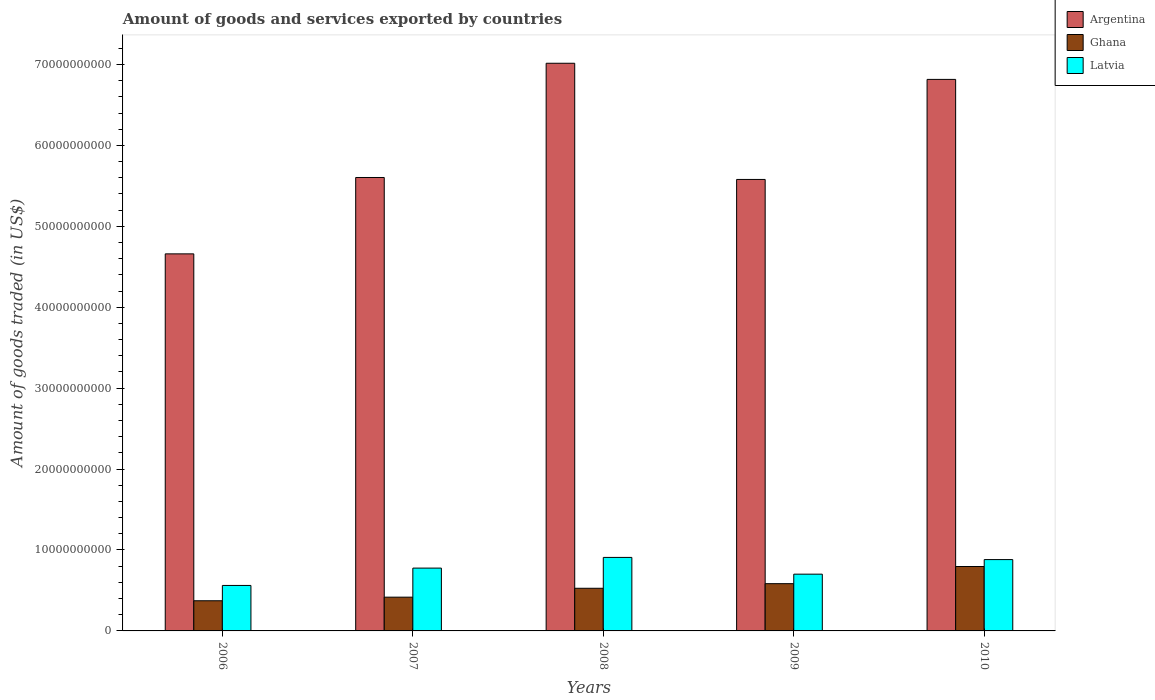How many groups of bars are there?
Provide a short and direct response. 5. What is the label of the 1st group of bars from the left?
Your answer should be compact. 2006. In how many cases, is the number of bars for a given year not equal to the number of legend labels?
Make the answer very short. 0. What is the total amount of goods and services exported in Ghana in 2009?
Offer a very short reply. 5.84e+09. Across all years, what is the maximum total amount of goods and services exported in Ghana?
Provide a short and direct response. 7.96e+09. Across all years, what is the minimum total amount of goods and services exported in Argentina?
Offer a terse response. 4.66e+1. What is the total total amount of goods and services exported in Latvia in the graph?
Your answer should be very brief. 3.83e+1. What is the difference between the total amount of goods and services exported in Ghana in 2006 and that in 2009?
Ensure brevity in your answer.  -2.11e+09. What is the difference between the total amount of goods and services exported in Latvia in 2007 and the total amount of goods and services exported in Ghana in 2009?
Your response must be concise. 1.92e+09. What is the average total amount of goods and services exported in Latvia per year?
Offer a very short reply. 7.66e+09. In the year 2006, what is the difference between the total amount of goods and services exported in Latvia and total amount of goods and services exported in Argentina?
Offer a terse response. -4.10e+1. What is the ratio of the total amount of goods and services exported in Argentina in 2007 to that in 2009?
Make the answer very short. 1. Is the total amount of goods and services exported in Ghana in 2006 less than that in 2009?
Keep it short and to the point. Yes. Is the difference between the total amount of goods and services exported in Latvia in 2009 and 2010 greater than the difference between the total amount of goods and services exported in Argentina in 2009 and 2010?
Your answer should be very brief. Yes. What is the difference between the highest and the second highest total amount of goods and services exported in Ghana?
Your answer should be very brief. 2.12e+09. What is the difference between the highest and the lowest total amount of goods and services exported in Latvia?
Your answer should be compact. 3.46e+09. Is the sum of the total amount of goods and services exported in Latvia in 2006 and 2008 greater than the maximum total amount of goods and services exported in Argentina across all years?
Provide a short and direct response. No. What does the 2nd bar from the left in 2009 represents?
Offer a terse response. Ghana. What does the 1st bar from the right in 2007 represents?
Your response must be concise. Latvia. How many bars are there?
Provide a succinct answer. 15. Are the values on the major ticks of Y-axis written in scientific E-notation?
Provide a short and direct response. No. What is the title of the graph?
Provide a succinct answer. Amount of goods and services exported by countries. Does "Nigeria" appear as one of the legend labels in the graph?
Your answer should be compact. No. What is the label or title of the Y-axis?
Provide a short and direct response. Amount of goods traded (in US$). What is the Amount of goods traded (in US$) in Argentina in 2006?
Make the answer very short. 4.66e+1. What is the Amount of goods traded (in US$) of Ghana in 2006?
Your response must be concise. 3.73e+09. What is the Amount of goods traded (in US$) in Latvia in 2006?
Your answer should be compact. 5.62e+09. What is the Amount of goods traded (in US$) of Argentina in 2007?
Provide a short and direct response. 5.60e+1. What is the Amount of goods traded (in US$) of Ghana in 2007?
Provide a succinct answer. 4.17e+09. What is the Amount of goods traded (in US$) in Latvia in 2007?
Your answer should be very brief. 7.76e+09. What is the Amount of goods traded (in US$) of Argentina in 2008?
Offer a very short reply. 7.01e+1. What is the Amount of goods traded (in US$) of Ghana in 2008?
Your answer should be compact. 5.27e+09. What is the Amount of goods traded (in US$) in Latvia in 2008?
Your answer should be very brief. 9.08e+09. What is the Amount of goods traded (in US$) in Argentina in 2009?
Ensure brevity in your answer.  5.58e+1. What is the Amount of goods traded (in US$) in Ghana in 2009?
Offer a terse response. 5.84e+09. What is the Amount of goods traded (in US$) of Latvia in 2009?
Provide a succinct answer. 7.01e+09. What is the Amount of goods traded (in US$) in Argentina in 2010?
Make the answer very short. 6.82e+1. What is the Amount of goods traded (in US$) in Ghana in 2010?
Provide a succinct answer. 7.96e+09. What is the Amount of goods traded (in US$) in Latvia in 2010?
Provide a succinct answer. 8.81e+09. Across all years, what is the maximum Amount of goods traded (in US$) of Argentina?
Offer a terse response. 7.01e+1. Across all years, what is the maximum Amount of goods traded (in US$) of Ghana?
Make the answer very short. 7.96e+09. Across all years, what is the maximum Amount of goods traded (in US$) of Latvia?
Ensure brevity in your answer.  9.08e+09. Across all years, what is the minimum Amount of goods traded (in US$) in Argentina?
Provide a short and direct response. 4.66e+1. Across all years, what is the minimum Amount of goods traded (in US$) in Ghana?
Provide a succinct answer. 3.73e+09. Across all years, what is the minimum Amount of goods traded (in US$) of Latvia?
Your answer should be compact. 5.62e+09. What is the total Amount of goods traded (in US$) in Argentina in the graph?
Ensure brevity in your answer.  2.97e+11. What is the total Amount of goods traded (in US$) in Ghana in the graph?
Provide a succinct answer. 2.70e+1. What is the total Amount of goods traded (in US$) of Latvia in the graph?
Offer a terse response. 3.83e+1. What is the difference between the Amount of goods traded (in US$) in Argentina in 2006 and that in 2007?
Your answer should be compact. -9.44e+09. What is the difference between the Amount of goods traded (in US$) of Ghana in 2006 and that in 2007?
Keep it short and to the point. -4.45e+08. What is the difference between the Amount of goods traded (in US$) in Latvia in 2006 and that in 2007?
Ensure brevity in your answer.  -2.14e+09. What is the difference between the Amount of goods traded (in US$) in Argentina in 2006 and that in 2008?
Provide a succinct answer. -2.36e+1. What is the difference between the Amount of goods traded (in US$) in Ghana in 2006 and that in 2008?
Keep it short and to the point. -1.54e+09. What is the difference between the Amount of goods traded (in US$) of Latvia in 2006 and that in 2008?
Provide a short and direct response. -3.46e+09. What is the difference between the Amount of goods traded (in US$) in Argentina in 2006 and that in 2009?
Provide a short and direct response. -9.20e+09. What is the difference between the Amount of goods traded (in US$) of Ghana in 2006 and that in 2009?
Provide a short and direct response. -2.11e+09. What is the difference between the Amount of goods traded (in US$) in Latvia in 2006 and that in 2009?
Ensure brevity in your answer.  -1.39e+09. What is the difference between the Amount of goods traded (in US$) in Argentina in 2006 and that in 2010?
Ensure brevity in your answer.  -2.16e+1. What is the difference between the Amount of goods traded (in US$) in Ghana in 2006 and that in 2010?
Offer a very short reply. -4.23e+09. What is the difference between the Amount of goods traded (in US$) of Latvia in 2006 and that in 2010?
Offer a very short reply. -3.20e+09. What is the difference between the Amount of goods traded (in US$) of Argentina in 2007 and that in 2008?
Provide a succinct answer. -1.41e+1. What is the difference between the Amount of goods traded (in US$) in Ghana in 2007 and that in 2008?
Provide a succinct answer. -1.10e+09. What is the difference between the Amount of goods traded (in US$) in Latvia in 2007 and that in 2008?
Your response must be concise. -1.32e+09. What is the difference between the Amount of goods traded (in US$) of Argentina in 2007 and that in 2009?
Provide a short and direct response. 2.42e+08. What is the difference between the Amount of goods traded (in US$) of Ghana in 2007 and that in 2009?
Give a very brief answer. -1.67e+09. What is the difference between the Amount of goods traded (in US$) of Latvia in 2007 and that in 2009?
Provide a short and direct response. 7.49e+08. What is the difference between the Amount of goods traded (in US$) in Argentina in 2007 and that in 2010?
Ensure brevity in your answer.  -1.21e+1. What is the difference between the Amount of goods traded (in US$) of Ghana in 2007 and that in 2010?
Give a very brief answer. -3.79e+09. What is the difference between the Amount of goods traded (in US$) of Latvia in 2007 and that in 2010?
Offer a terse response. -1.05e+09. What is the difference between the Amount of goods traded (in US$) of Argentina in 2008 and that in 2009?
Your response must be concise. 1.44e+1. What is the difference between the Amount of goods traded (in US$) of Ghana in 2008 and that in 2009?
Offer a terse response. -5.70e+08. What is the difference between the Amount of goods traded (in US$) of Latvia in 2008 and that in 2009?
Offer a terse response. 2.07e+09. What is the difference between the Amount of goods traded (in US$) of Argentina in 2008 and that in 2010?
Provide a succinct answer. 1.99e+09. What is the difference between the Amount of goods traded (in US$) of Ghana in 2008 and that in 2010?
Offer a terse response. -2.69e+09. What is the difference between the Amount of goods traded (in US$) in Latvia in 2008 and that in 2010?
Your answer should be very brief. 2.68e+08. What is the difference between the Amount of goods traded (in US$) in Argentina in 2009 and that in 2010?
Ensure brevity in your answer.  -1.24e+1. What is the difference between the Amount of goods traded (in US$) in Ghana in 2009 and that in 2010?
Your response must be concise. -2.12e+09. What is the difference between the Amount of goods traded (in US$) of Latvia in 2009 and that in 2010?
Give a very brief answer. -1.80e+09. What is the difference between the Amount of goods traded (in US$) of Argentina in 2006 and the Amount of goods traded (in US$) of Ghana in 2007?
Your answer should be compact. 4.24e+1. What is the difference between the Amount of goods traded (in US$) in Argentina in 2006 and the Amount of goods traded (in US$) in Latvia in 2007?
Give a very brief answer. 3.88e+1. What is the difference between the Amount of goods traded (in US$) of Ghana in 2006 and the Amount of goods traded (in US$) of Latvia in 2007?
Offer a terse response. -4.04e+09. What is the difference between the Amount of goods traded (in US$) in Argentina in 2006 and the Amount of goods traded (in US$) in Ghana in 2008?
Provide a short and direct response. 4.13e+1. What is the difference between the Amount of goods traded (in US$) in Argentina in 2006 and the Amount of goods traded (in US$) in Latvia in 2008?
Make the answer very short. 3.75e+1. What is the difference between the Amount of goods traded (in US$) in Ghana in 2006 and the Amount of goods traded (in US$) in Latvia in 2008?
Provide a short and direct response. -5.36e+09. What is the difference between the Amount of goods traded (in US$) in Argentina in 2006 and the Amount of goods traded (in US$) in Ghana in 2009?
Provide a short and direct response. 4.08e+1. What is the difference between the Amount of goods traded (in US$) of Argentina in 2006 and the Amount of goods traded (in US$) of Latvia in 2009?
Ensure brevity in your answer.  3.96e+1. What is the difference between the Amount of goods traded (in US$) in Ghana in 2006 and the Amount of goods traded (in US$) in Latvia in 2009?
Your answer should be compact. -3.29e+09. What is the difference between the Amount of goods traded (in US$) of Argentina in 2006 and the Amount of goods traded (in US$) of Ghana in 2010?
Offer a terse response. 3.86e+1. What is the difference between the Amount of goods traded (in US$) in Argentina in 2006 and the Amount of goods traded (in US$) in Latvia in 2010?
Ensure brevity in your answer.  3.78e+1. What is the difference between the Amount of goods traded (in US$) of Ghana in 2006 and the Amount of goods traded (in US$) of Latvia in 2010?
Ensure brevity in your answer.  -5.09e+09. What is the difference between the Amount of goods traded (in US$) of Argentina in 2007 and the Amount of goods traded (in US$) of Ghana in 2008?
Provide a succinct answer. 5.08e+1. What is the difference between the Amount of goods traded (in US$) in Argentina in 2007 and the Amount of goods traded (in US$) in Latvia in 2008?
Offer a very short reply. 4.69e+1. What is the difference between the Amount of goods traded (in US$) of Ghana in 2007 and the Amount of goods traded (in US$) of Latvia in 2008?
Your response must be concise. -4.91e+09. What is the difference between the Amount of goods traded (in US$) in Argentina in 2007 and the Amount of goods traded (in US$) in Ghana in 2009?
Ensure brevity in your answer.  5.02e+1. What is the difference between the Amount of goods traded (in US$) of Argentina in 2007 and the Amount of goods traded (in US$) of Latvia in 2009?
Give a very brief answer. 4.90e+1. What is the difference between the Amount of goods traded (in US$) of Ghana in 2007 and the Amount of goods traded (in US$) of Latvia in 2009?
Your answer should be compact. -2.84e+09. What is the difference between the Amount of goods traded (in US$) in Argentina in 2007 and the Amount of goods traded (in US$) in Ghana in 2010?
Your answer should be very brief. 4.81e+1. What is the difference between the Amount of goods traded (in US$) in Argentina in 2007 and the Amount of goods traded (in US$) in Latvia in 2010?
Ensure brevity in your answer.  4.72e+1. What is the difference between the Amount of goods traded (in US$) in Ghana in 2007 and the Amount of goods traded (in US$) in Latvia in 2010?
Ensure brevity in your answer.  -4.64e+09. What is the difference between the Amount of goods traded (in US$) of Argentina in 2008 and the Amount of goods traded (in US$) of Ghana in 2009?
Your response must be concise. 6.43e+1. What is the difference between the Amount of goods traded (in US$) in Argentina in 2008 and the Amount of goods traded (in US$) in Latvia in 2009?
Keep it short and to the point. 6.31e+1. What is the difference between the Amount of goods traded (in US$) of Ghana in 2008 and the Amount of goods traded (in US$) of Latvia in 2009?
Your response must be concise. -1.74e+09. What is the difference between the Amount of goods traded (in US$) of Argentina in 2008 and the Amount of goods traded (in US$) of Ghana in 2010?
Ensure brevity in your answer.  6.22e+1. What is the difference between the Amount of goods traded (in US$) in Argentina in 2008 and the Amount of goods traded (in US$) in Latvia in 2010?
Offer a very short reply. 6.13e+1. What is the difference between the Amount of goods traded (in US$) in Ghana in 2008 and the Amount of goods traded (in US$) in Latvia in 2010?
Your answer should be compact. -3.54e+09. What is the difference between the Amount of goods traded (in US$) of Argentina in 2009 and the Amount of goods traded (in US$) of Ghana in 2010?
Give a very brief answer. 4.78e+1. What is the difference between the Amount of goods traded (in US$) in Argentina in 2009 and the Amount of goods traded (in US$) in Latvia in 2010?
Give a very brief answer. 4.70e+1. What is the difference between the Amount of goods traded (in US$) in Ghana in 2009 and the Amount of goods traded (in US$) in Latvia in 2010?
Give a very brief answer. -2.97e+09. What is the average Amount of goods traded (in US$) of Argentina per year?
Provide a succinct answer. 5.93e+1. What is the average Amount of goods traded (in US$) in Ghana per year?
Your answer should be compact. 5.39e+09. What is the average Amount of goods traded (in US$) in Latvia per year?
Make the answer very short. 7.66e+09. In the year 2006, what is the difference between the Amount of goods traded (in US$) of Argentina and Amount of goods traded (in US$) of Ghana?
Your response must be concise. 4.29e+1. In the year 2006, what is the difference between the Amount of goods traded (in US$) of Argentina and Amount of goods traded (in US$) of Latvia?
Your response must be concise. 4.10e+1. In the year 2006, what is the difference between the Amount of goods traded (in US$) of Ghana and Amount of goods traded (in US$) of Latvia?
Your answer should be compact. -1.89e+09. In the year 2007, what is the difference between the Amount of goods traded (in US$) of Argentina and Amount of goods traded (in US$) of Ghana?
Offer a terse response. 5.19e+1. In the year 2007, what is the difference between the Amount of goods traded (in US$) of Argentina and Amount of goods traded (in US$) of Latvia?
Ensure brevity in your answer.  4.83e+1. In the year 2007, what is the difference between the Amount of goods traded (in US$) in Ghana and Amount of goods traded (in US$) in Latvia?
Make the answer very short. -3.59e+09. In the year 2008, what is the difference between the Amount of goods traded (in US$) of Argentina and Amount of goods traded (in US$) of Ghana?
Offer a terse response. 6.49e+1. In the year 2008, what is the difference between the Amount of goods traded (in US$) in Argentina and Amount of goods traded (in US$) in Latvia?
Offer a terse response. 6.11e+1. In the year 2008, what is the difference between the Amount of goods traded (in US$) in Ghana and Amount of goods traded (in US$) in Latvia?
Ensure brevity in your answer.  -3.81e+09. In the year 2009, what is the difference between the Amount of goods traded (in US$) in Argentina and Amount of goods traded (in US$) in Ghana?
Provide a short and direct response. 5.00e+1. In the year 2009, what is the difference between the Amount of goods traded (in US$) in Argentina and Amount of goods traded (in US$) in Latvia?
Your answer should be compact. 4.88e+1. In the year 2009, what is the difference between the Amount of goods traded (in US$) in Ghana and Amount of goods traded (in US$) in Latvia?
Keep it short and to the point. -1.17e+09. In the year 2010, what is the difference between the Amount of goods traded (in US$) in Argentina and Amount of goods traded (in US$) in Ghana?
Ensure brevity in your answer.  6.02e+1. In the year 2010, what is the difference between the Amount of goods traded (in US$) in Argentina and Amount of goods traded (in US$) in Latvia?
Offer a terse response. 5.93e+1. In the year 2010, what is the difference between the Amount of goods traded (in US$) in Ghana and Amount of goods traded (in US$) in Latvia?
Provide a succinct answer. -8.54e+08. What is the ratio of the Amount of goods traded (in US$) of Argentina in 2006 to that in 2007?
Your response must be concise. 0.83. What is the ratio of the Amount of goods traded (in US$) of Ghana in 2006 to that in 2007?
Offer a very short reply. 0.89. What is the ratio of the Amount of goods traded (in US$) in Latvia in 2006 to that in 2007?
Ensure brevity in your answer.  0.72. What is the ratio of the Amount of goods traded (in US$) of Argentina in 2006 to that in 2008?
Offer a very short reply. 0.66. What is the ratio of the Amount of goods traded (in US$) in Ghana in 2006 to that in 2008?
Keep it short and to the point. 0.71. What is the ratio of the Amount of goods traded (in US$) of Latvia in 2006 to that in 2008?
Your answer should be very brief. 0.62. What is the ratio of the Amount of goods traded (in US$) in Argentina in 2006 to that in 2009?
Keep it short and to the point. 0.84. What is the ratio of the Amount of goods traded (in US$) in Ghana in 2006 to that in 2009?
Your answer should be very brief. 0.64. What is the ratio of the Amount of goods traded (in US$) in Latvia in 2006 to that in 2009?
Offer a terse response. 0.8. What is the ratio of the Amount of goods traded (in US$) in Argentina in 2006 to that in 2010?
Ensure brevity in your answer.  0.68. What is the ratio of the Amount of goods traded (in US$) of Ghana in 2006 to that in 2010?
Keep it short and to the point. 0.47. What is the ratio of the Amount of goods traded (in US$) of Latvia in 2006 to that in 2010?
Keep it short and to the point. 0.64. What is the ratio of the Amount of goods traded (in US$) of Argentina in 2007 to that in 2008?
Offer a very short reply. 0.8. What is the ratio of the Amount of goods traded (in US$) in Ghana in 2007 to that in 2008?
Offer a terse response. 0.79. What is the ratio of the Amount of goods traded (in US$) of Latvia in 2007 to that in 2008?
Provide a short and direct response. 0.85. What is the ratio of the Amount of goods traded (in US$) of Ghana in 2007 to that in 2009?
Your answer should be compact. 0.71. What is the ratio of the Amount of goods traded (in US$) of Latvia in 2007 to that in 2009?
Offer a very short reply. 1.11. What is the ratio of the Amount of goods traded (in US$) in Argentina in 2007 to that in 2010?
Provide a short and direct response. 0.82. What is the ratio of the Amount of goods traded (in US$) in Ghana in 2007 to that in 2010?
Keep it short and to the point. 0.52. What is the ratio of the Amount of goods traded (in US$) of Latvia in 2007 to that in 2010?
Your answer should be very brief. 0.88. What is the ratio of the Amount of goods traded (in US$) of Argentina in 2008 to that in 2009?
Your answer should be compact. 1.26. What is the ratio of the Amount of goods traded (in US$) in Ghana in 2008 to that in 2009?
Offer a terse response. 0.9. What is the ratio of the Amount of goods traded (in US$) of Latvia in 2008 to that in 2009?
Make the answer very short. 1.29. What is the ratio of the Amount of goods traded (in US$) of Argentina in 2008 to that in 2010?
Offer a very short reply. 1.03. What is the ratio of the Amount of goods traded (in US$) of Ghana in 2008 to that in 2010?
Keep it short and to the point. 0.66. What is the ratio of the Amount of goods traded (in US$) in Latvia in 2008 to that in 2010?
Your answer should be very brief. 1.03. What is the ratio of the Amount of goods traded (in US$) in Argentina in 2009 to that in 2010?
Your response must be concise. 0.82. What is the ratio of the Amount of goods traded (in US$) in Ghana in 2009 to that in 2010?
Your answer should be very brief. 0.73. What is the ratio of the Amount of goods traded (in US$) of Latvia in 2009 to that in 2010?
Your answer should be very brief. 0.8. What is the difference between the highest and the second highest Amount of goods traded (in US$) in Argentina?
Provide a succinct answer. 1.99e+09. What is the difference between the highest and the second highest Amount of goods traded (in US$) of Ghana?
Provide a succinct answer. 2.12e+09. What is the difference between the highest and the second highest Amount of goods traded (in US$) in Latvia?
Offer a very short reply. 2.68e+08. What is the difference between the highest and the lowest Amount of goods traded (in US$) in Argentina?
Keep it short and to the point. 2.36e+1. What is the difference between the highest and the lowest Amount of goods traded (in US$) of Ghana?
Provide a succinct answer. 4.23e+09. What is the difference between the highest and the lowest Amount of goods traded (in US$) in Latvia?
Make the answer very short. 3.46e+09. 